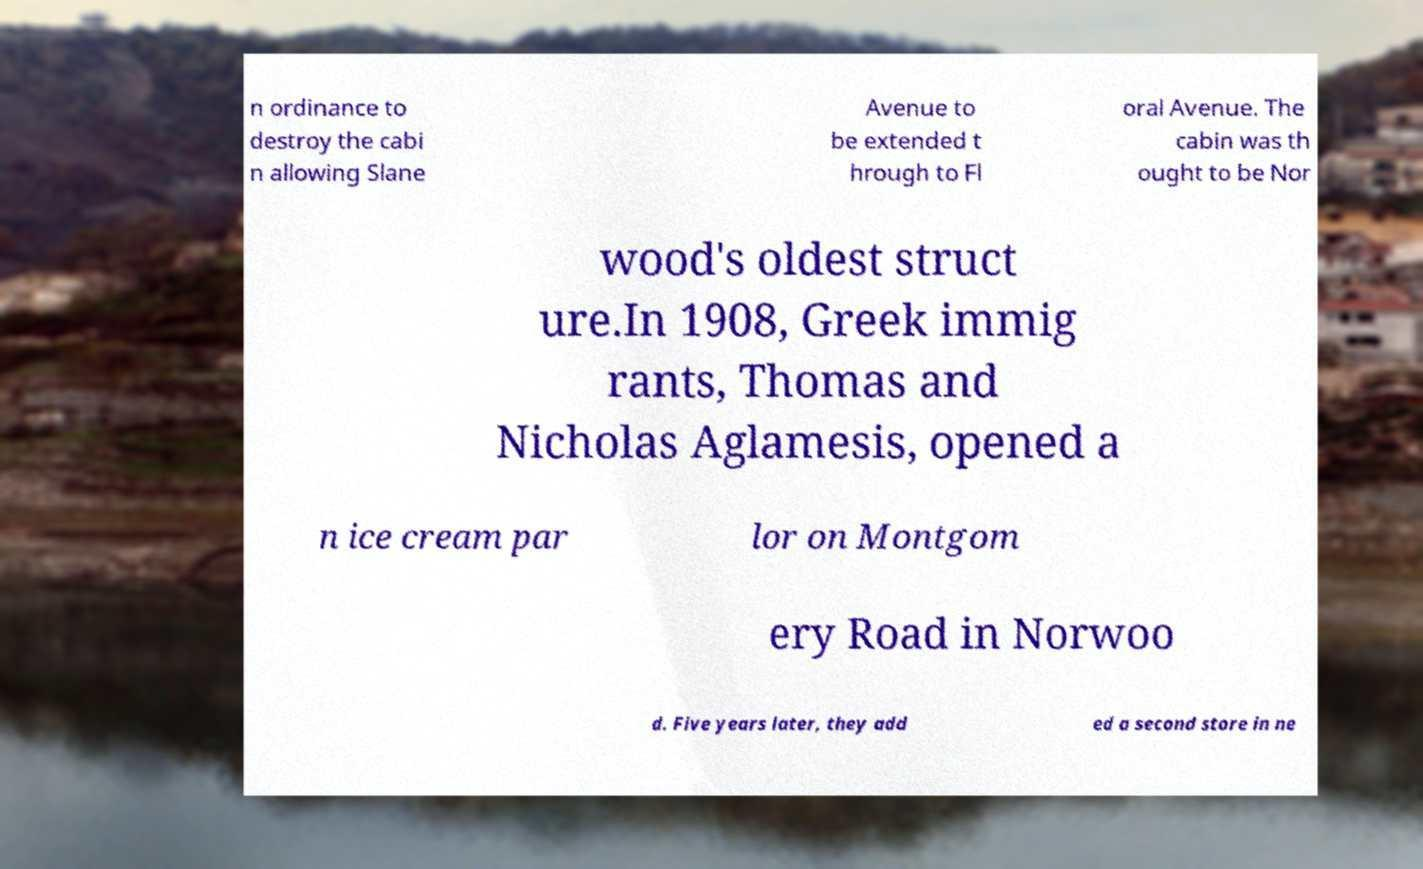Please read and relay the text visible in this image. What does it say? n ordinance to destroy the cabi n allowing Slane Avenue to be extended t hrough to Fl oral Avenue. The cabin was th ought to be Nor wood's oldest struct ure.In 1908, Greek immig rants, Thomas and Nicholas Aglamesis, opened a n ice cream par lor on Montgom ery Road in Norwoo d. Five years later, they add ed a second store in ne 